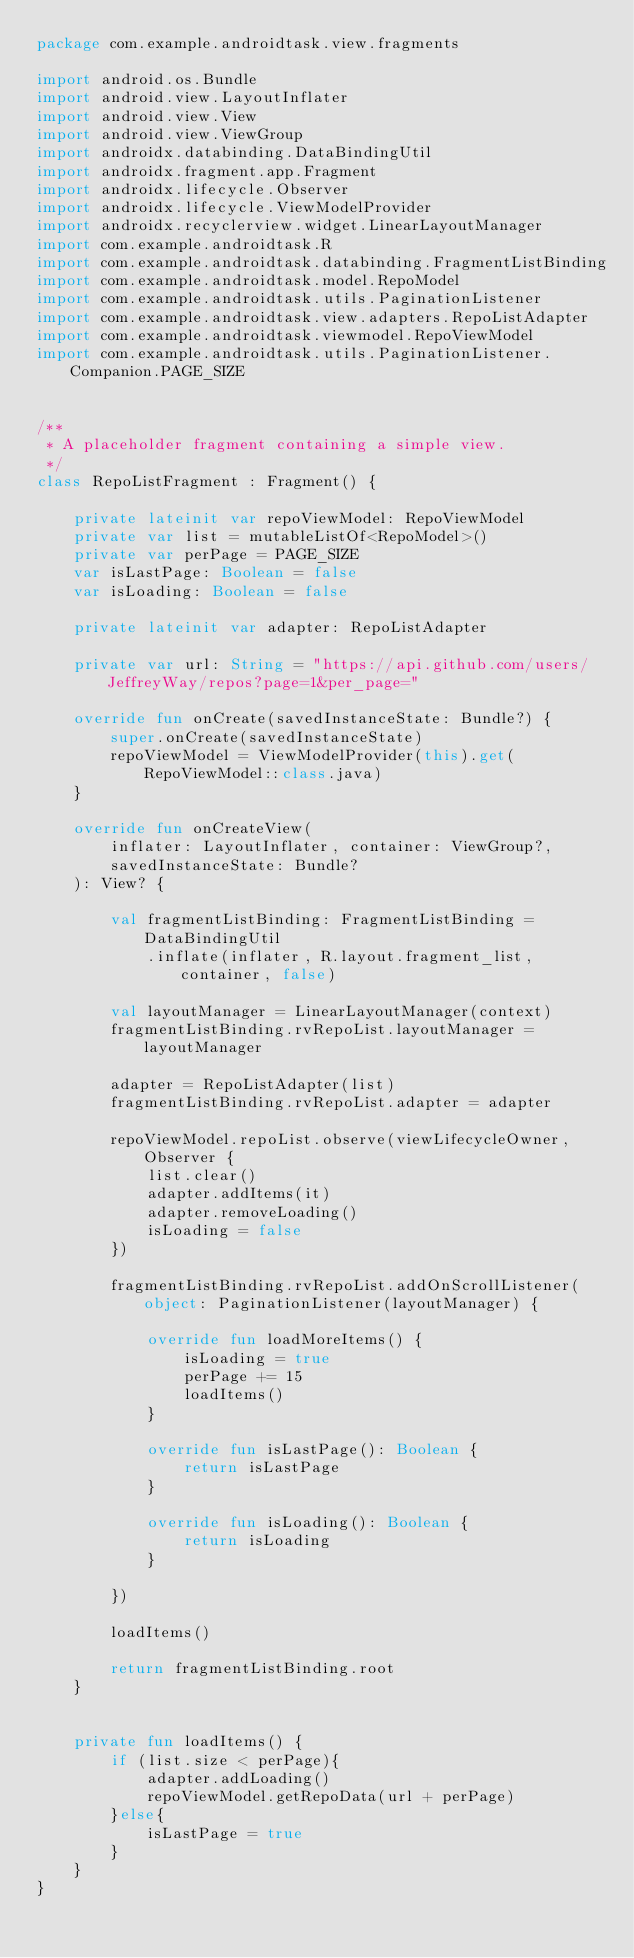<code> <loc_0><loc_0><loc_500><loc_500><_Kotlin_>package com.example.androidtask.view.fragments

import android.os.Bundle
import android.view.LayoutInflater
import android.view.View
import android.view.ViewGroup
import androidx.databinding.DataBindingUtil
import androidx.fragment.app.Fragment
import androidx.lifecycle.Observer
import androidx.lifecycle.ViewModelProvider
import androidx.recyclerview.widget.LinearLayoutManager
import com.example.androidtask.R
import com.example.androidtask.databinding.FragmentListBinding
import com.example.androidtask.model.RepoModel
import com.example.androidtask.utils.PaginationListener
import com.example.androidtask.view.adapters.RepoListAdapter
import com.example.androidtask.viewmodel.RepoViewModel
import com.example.androidtask.utils.PaginationListener.Companion.PAGE_SIZE


/**
 * A placeholder fragment containing a simple view.
 */
class RepoListFragment : Fragment() {

    private lateinit var repoViewModel: RepoViewModel
    private var list = mutableListOf<RepoModel>()
    private var perPage = PAGE_SIZE
    var isLastPage: Boolean = false
    var isLoading: Boolean = false

    private lateinit var adapter: RepoListAdapter

    private var url: String = "https://api.github.com/users/JeffreyWay/repos?page=1&per_page="

    override fun onCreate(savedInstanceState: Bundle?) {
        super.onCreate(savedInstanceState)
        repoViewModel = ViewModelProvider(this).get(RepoViewModel::class.java)
    }

    override fun onCreateView(
        inflater: LayoutInflater, container: ViewGroup?,
        savedInstanceState: Bundle?
    ): View? {

        val fragmentListBinding: FragmentListBinding = DataBindingUtil
            .inflate(inflater, R.layout.fragment_list, container, false)

        val layoutManager = LinearLayoutManager(context)
        fragmentListBinding.rvRepoList.layoutManager = layoutManager

        adapter = RepoListAdapter(list)
        fragmentListBinding.rvRepoList.adapter = adapter

        repoViewModel.repoList.observe(viewLifecycleOwner, Observer {
            list.clear()
            adapter.addItems(it)
            adapter.removeLoading()
            isLoading = false
        })

        fragmentListBinding.rvRepoList.addOnScrollListener(object: PaginationListener(layoutManager) {

            override fun loadMoreItems() {
                isLoading = true
                perPage += 15
                loadItems()
            }

            override fun isLastPage(): Boolean {
                return isLastPage
            }

            override fun isLoading(): Boolean {
                return isLoading
            }

        })

        loadItems()

        return fragmentListBinding.root
    }


    private fun loadItems() {
        if (list.size < perPage){
            adapter.addLoading()
            repoViewModel.getRepoData(url + perPage)
        }else{
            isLastPage = true
        }
    }
}</code> 